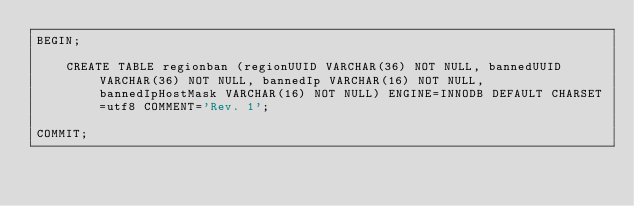<code> <loc_0><loc_0><loc_500><loc_500><_SQL_>BEGIN;
	
	CREATE TABLE regionban (regionUUID VARCHAR(36) NOT NULL, bannedUUID VARCHAR(36) NOT NULL, bannedIp VARCHAR(16) NOT NULL, bannedIpHostMask VARCHAR(16) NOT NULL) ENGINE=INNODB DEFAULT CHARSET=utf8 COMMENT='Rev. 1';

COMMIT;</code> 